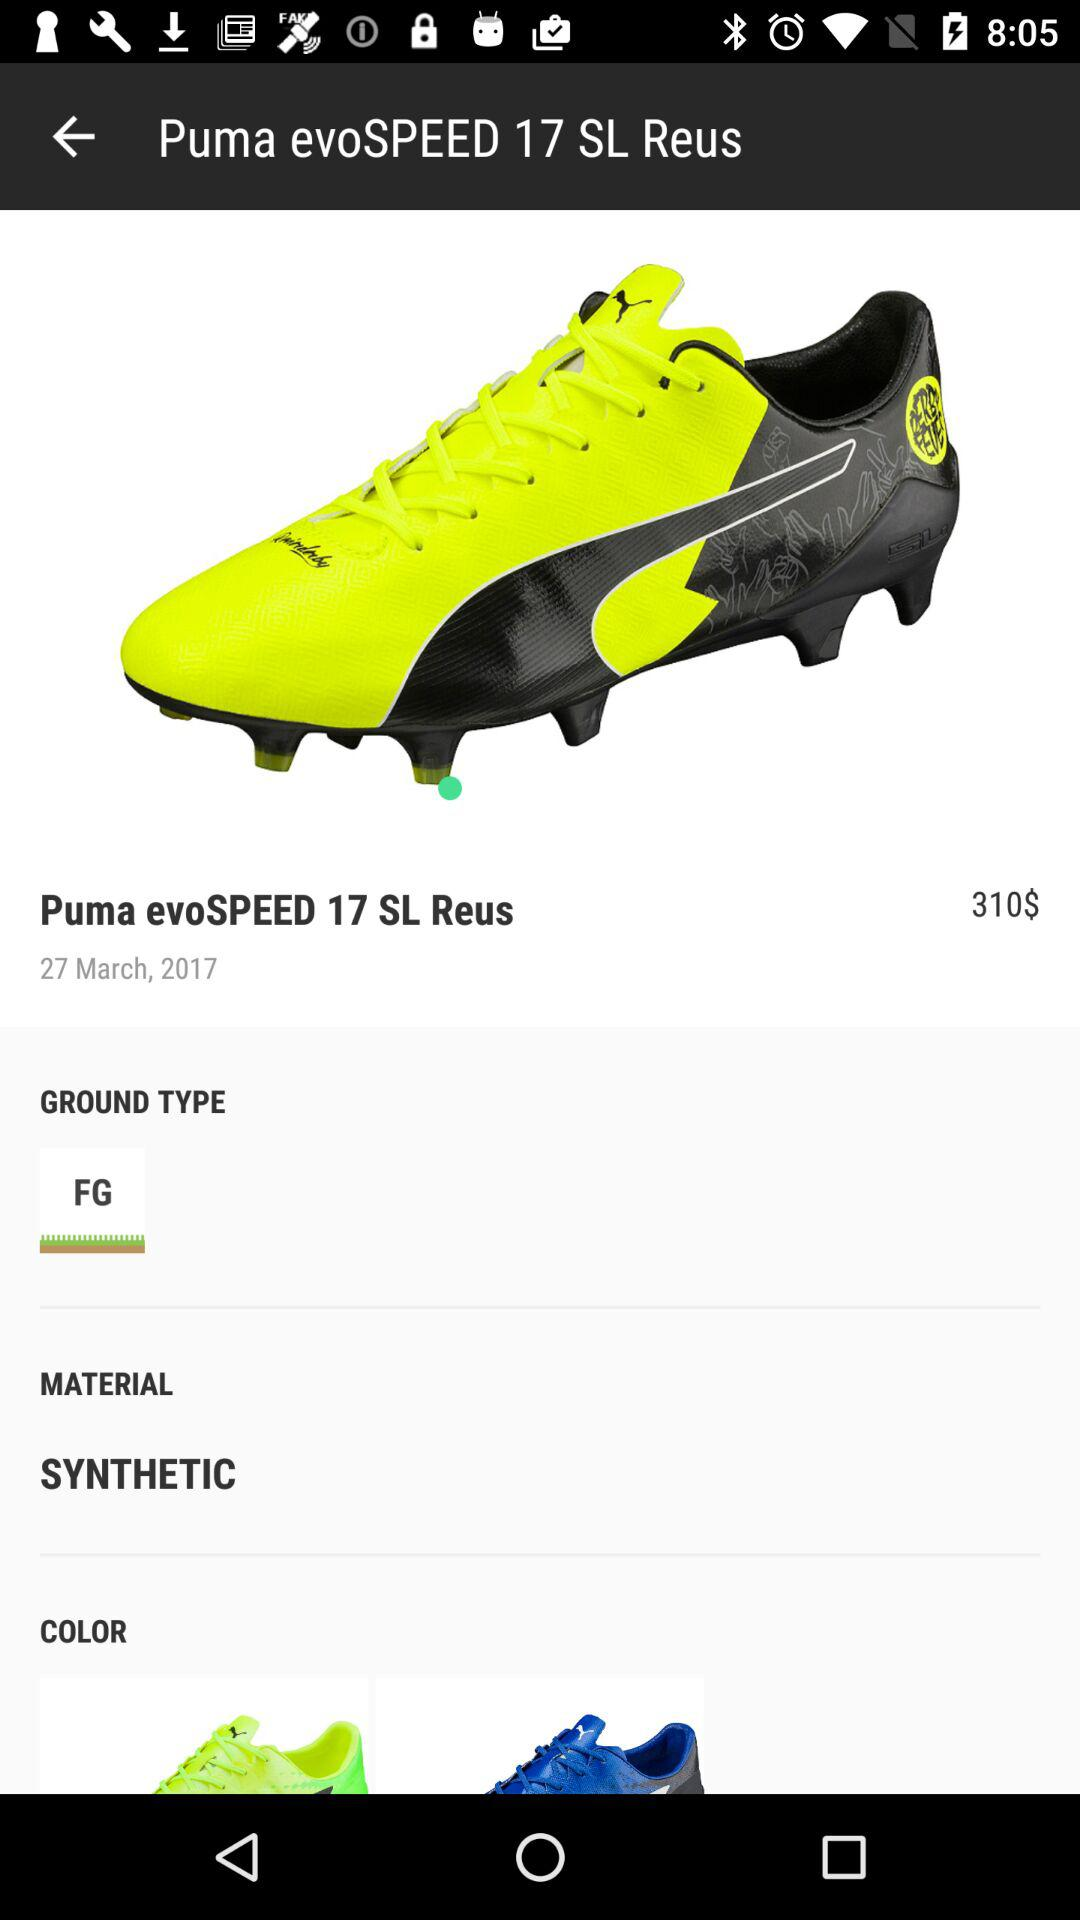What is the ground type of the shoe? The ground type of the shoe is "FG". 